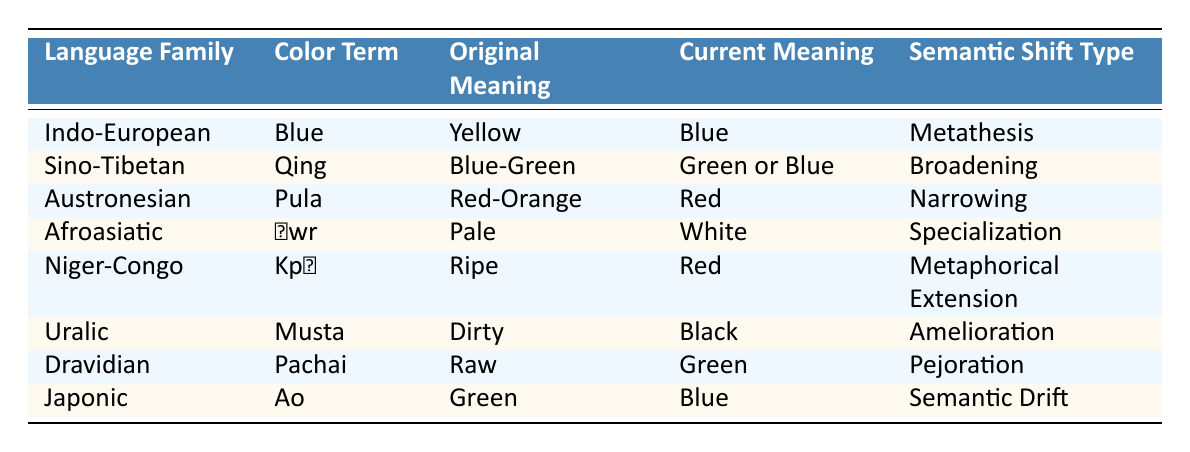What is the original meaning of the color term "Qing" in the Sino-Tibetan language family? According to the table, the original meaning of "Qing" is listed as "Blue-Green" under the Sino-Tibetan language family.
Answer: Blue-Green Which color term has undergone metathesis in the Indo-European language family? The table shows that the color term "Blue" in the Indo-European language family has undergone metathesis, where the original meaning was "Yellow".
Answer: Blue Is the semantic shift type for "Pula" in the Austronesian language family specialization? The table indicates that the semantic shift type for "Pula" is "Narrowing", not "Specialization". Therefore, the statement is false.
Answer: No What is the current meaning of the color term "Ḥwr" in the Afroasiatic family? The current meaning of "Ḥwr" is shown as "White" in the table, so this is the direct answer.
Answer: White Which color terms have undergone a metaphorical extension? From the table, the only color term that has undergone metaphorical extension is "Kpɛ" in the Niger-Congo language family, where the original meaning was "Ripe" and the current meaning is "Red".
Answer: Kpɛ What is the difference in original meanings between "Musta" and "Pachai"? The original meaning of "Musta" is "Dirty", and the original meaning of "Pachai" is "Raw". The difference between these original meanings in terms of description is one focuses on cleanliness ("Dirty") while the other pertains to freshness ("Raw").
Answer: Not applicable Which color term has the current meaning of "Green" and what was its original meaning? The table shows that "Pachai" has the current meaning of "Green" with the original meaning being "Raw". This provides both the current meaning and the original meaning of the specified color term.
Answer: Pachai: Raw What is the relationship between the original meaning "Pale" and the current meaning "White"? The table indicates that "Ḥwr" in Afroasiatic starts as "Pale" and shifts to "White". This shows a specialization shift where the original term is now more specifically defined than before.
Answer: Specialization How many color terms have undergone a semantic drift? The table indicates that only "Ao" in the Japonic language family has undergone a semantic drift, changing from "Green" to "Blue". Therefore, there is just one term that fits this description.
Answer: One 